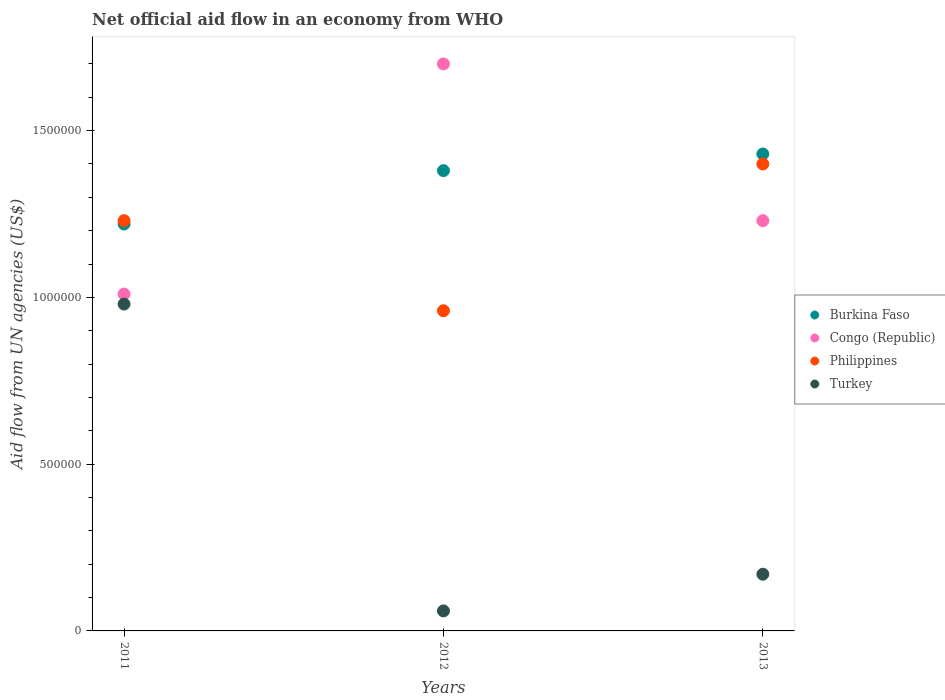Is the number of dotlines equal to the number of legend labels?
Offer a very short reply. Yes. What is the net official aid flow in Burkina Faso in 2012?
Offer a terse response. 1.38e+06. Across all years, what is the maximum net official aid flow in Philippines?
Your response must be concise. 1.40e+06. Across all years, what is the minimum net official aid flow in Burkina Faso?
Provide a short and direct response. 1.22e+06. In which year was the net official aid flow in Philippines maximum?
Make the answer very short. 2013. What is the total net official aid flow in Burkina Faso in the graph?
Give a very brief answer. 4.03e+06. What is the difference between the net official aid flow in Turkey in 2011 and that in 2012?
Keep it short and to the point. 9.20e+05. What is the difference between the net official aid flow in Turkey in 2013 and the net official aid flow in Congo (Republic) in 2012?
Keep it short and to the point. -1.53e+06. What is the average net official aid flow in Philippines per year?
Make the answer very short. 1.20e+06. In the year 2011, what is the difference between the net official aid flow in Philippines and net official aid flow in Burkina Faso?
Keep it short and to the point. 10000. What is the ratio of the net official aid flow in Congo (Republic) in 2012 to that in 2013?
Your answer should be very brief. 1.38. Is the net official aid flow in Philippines in 2012 less than that in 2013?
Ensure brevity in your answer.  Yes. What is the difference between the highest and the second highest net official aid flow in Turkey?
Ensure brevity in your answer.  8.10e+05. Is the sum of the net official aid flow in Congo (Republic) in 2012 and 2013 greater than the maximum net official aid flow in Turkey across all years?
Give a very brief answer. Yes. Is it the case that in every year, the sum of the net official aid flow in Burkina Faso and net official aid flow in Turkey  is greater than the sum of net official aid flow in Philippines and net official aid flow in Congo (Republic)?
Provide a short and direct response. No. Is it the case that in every year, the sum of the net official aid flow in Congo (Republic) and net official aid flow in Philippines  is greater than the net official aid flow in Burkina Faso?
Provide a short and direct response. Yes. Does the net official aid flow in Turkey monotonically increase over the years?
Provide a short and direct response. No. Is the net official aid flow in Philippines strictly greater than the net official aid flow in Congo (Republic) over the years?
Keep it short and to the point. No. How many dotlines are there?
Keep it short and to the point. 4. What is the difference between two consecutive major ticks on the Y-axis?
Offer a very short reply. 5.00e+05. Are the values on the major ticks of Y-axis written in scientific E-notation?
Provide a short and direct response. No. Does the graph contain any zero values?
Your response must be concise. No. Does the graph contain grids?
Your answer should be very brief. No. How many legend labels are there?
Make the answer very short. 4. What is the title of the graph?
Make the answer very short. Net official aid flow in an economy from WHO. Does "Euro area" appear as one of the legend labels in the graph?
Keep it short and to the point. No. What is the label or title of the X-axis?
Offer a very short reply. Years. What is the label or title of the Y-axis?
Your answer should be very brief. Aid flow from UN agencies (US$). What is the Aid flow from UN agencies (US$) of Burkina Faso in 2011?
Your answer should be very brief. 1.22e+06. What is the Aid flow from UN agencies (US$) of Congo (Republic) in 2011?
Offer a very short reply. 1.01e+06. What is the Aid flow from UN agencies (US$) of Philippines in 2011?
Make the answer very short. 1.23e+06. What is the Aid flow from UN agencies (US$) of Turkey in 2011?
Your answer should be very brief. 9.80e+05. What is the Aid flow from UN agencies (US$) in Burkina Faso in 2012?
Your response must be concise. 1.38e+06. What is the Aid flow from UN agencies (US$) in Congo (Republic) in 2012?
Offer a terse response. 1.70e+06. What is the Aid flow from UN agencies (US$) of Philippines in 2012?
Your answer should be very brief. 9.60e+05. What is the Aid flow from UN agencies (US$) of Turkey in 2012?
Your answer should be compact. 6.00e+04. What is the Aid flow from UN agencies (US$) of Burkina Faso in 2013?
Your response must be concise. 1.43e+06. What is the Aid flow from UN agencies (US$) of Congo (Republic) in 2013?
Keep it short and to the point. 1.23e+06. What is the Aid flow from UN agencies (US$) of Philippines in 2013?
Provide a succinct answer. 1.40e+06. What is the Aid flow from UN agencies (US$) in Turkey in 2013?
Your response must be concise. 1.70e+05. Across all years, what is the maximum Aid flow from UN agencies (US$) of Burkina Faso?
Ensure brevity in your answer.  1.43e+06. Across all years, what is the maximum Aid flow from UN agencies (US$) of Congo (Republic)?
Offer a very short reply. 1.70e+06. Across all years, what is the maximum Aid flow from UN agencies (US$) of Philippines?
Your response must be concise. 1.40e+06. Across all years, what is the maximum Aid flow from UN agencies (US$) of Turkey?
Your answer should be compact. 9.80e+05. Across all years, what is the minimum Aid flow from UN agencies (US$) in Burkina Faso?
Ensure brevity in your answer.  1.22e+06. Across all years, what is the minimum Aid flow from UN agencies (US$) in Congo (Republic)?
Your response must be concise. 1.01e+06. Across all years, what is the minimum Aid flow from UN agencies (US$) in Philippines?
Your answer should be compact. 9.60e+05. Across all years, what is the minimum Aid flow from UN agencies (US$) of Turkey?
Your answer should be compact. 6.00e+04. What is the total Aid flow from UN agencies (US$) in Burkina Faso in the graph?
Give a very brief answer. 4.03e+06. What is the total Aid flow from UN agencies (US$) in Congo (Republic) in the graph?
Offer a very short reply. 3.94e+06. What is the total Aid flow from UN agencies (US$) in Philippines in the graph?
Provide a succinct answer. 3.59e+06. What is the total Aid flow from UN agencies (US$) of Turkey in the graph?
Your response must be concise. 1.21e+06. What is the difference between the Aid flow from UN agencies (US$) of Congo (Republic) in 2011 and that in 2012?
Your answer should be compact. -6.90e+05. What is the difference between the Aid flow from UN agencies (US$) in Turkey in 2011 and that in 2012?
Ensure brevity in your answer.  9.20e+05. What is the difference between the Aid flow from UN agencies (US$) in Burkina Faso in 2011 and that in 2013?
Provide a short and direct response. -2.10e+05. What is the difference between the Aid flow from UN agencies (US$) in Philippines in 2011 and that in 2013?
Keep it short and to the point. -1.70e+05. What is the difference between the Aid flow from UN agencies (US$) in Turkey in 2011 and that in 2013?
Your answer should be compact. 8.10e+05. What is the difference between the Aid flow from UN agencies (US$) of Congo (Republic) in 2012 and that in 2013?
Your response must be concise. 4.70e+05. What is the difference between the Aid flow from UN agencies (US$) in Philippines in 2012 and that in 2013?
Your answer should be compact. -4.40e+05. What is the difference between the Aid flow from UN agencies (US$) of Turkey in 2012 and that in 2013?
Offer a terse response. -1.10e+05. What is the difference between the Aid flow from UN agencies (US$) in Burkina Faso in 2011 and the Aid flow from UN agencies (US$) in Congo (Republic) in 2012?
Ensure brevity in your answer.  -4.80e+05. What is the difference between the Aid flow from UN agencies (US$) in Burkina Faso in 2011 and the Aid flow from UN agencies (US$) in Philippines in 2012?
Provide a succinct answer. 2.60e+05. What is the difference between the Aid flow from UN agencies (US$) of Burkina Faso in 2011 and the Aid flow from UN agencies (US$) of Turkey in 2012?
Provide a succinct answer. 1.16e+06. What is the difference between the Aid flow from UN agencies (US$) in Congo (Republic) in 2011 and the Aid flow from UN agencies (US$) in Philippines in 2012?
Give a very brief answer. 5.00e+04. What is the difference between the Aid flow from UN agencies (US$) in Congo (Republic) in 2011 and the Aid flow from UN agencies (US$) in Turkey in 2012?
Make the answer very short. 9.50e+05. What is the difference between the Aid flow from UN agencies (US$) of Philippines in 2011 and the Aid flow from UN agencies (US$) of Turkey in 2012?
Your answer should be very brief. 1.17e+06. What is the difference between the Aid flow from UN agencies (US$) in Burkina Faso in 2011 and the Aid flow from UN agencies (US$) in Congo (Republic) in 2013?
Make the answer very short. -10000. What is the difference between the Aid flow from UN agencies (US$) in Burkina Faso in 2011 and the Aid flow from UN agencies (US$) in Turkey in 2013?
Provide a short and direct response. 1.05e+06. What is the difference between the Aid flow from UN agencies (US$) of Congo (Republic) in 2011 and the Aid flow from UN agencies (US$) of Philippines in 2013?
Provide a succinct answer. -3.90e+05. What is the difference between the Aid flow from UN agencies (US$) in Congo (Republic) in 2011 and the Aid flow from UN agencies (US$) in Turkey in 2013?
Offer a terse response. 8.40e+05. What is the difference between the Aid flow from UN agencies (US$) of Philippines in 2011 and the Aid flow from UN agencies (US$) of Turkey in 2013?
Provide a succinct answer. 1.06e+06. What is the difference between the Aid flow from UN agencies (US$) of Burkina Faso in 2012 and the Aid flow from UN agencies (US$) of Philippines in 2013?
Provide a short and direct response. -2.00e+04. What is the difference between the Aid flow from UN agencies (US$) of Burkina Faso in 2012 and the Aid flow from UN agencies (US$) of Turkey in 2013?
Your answer should be compact. 1.21e+06. What is the difference between the Aid flow from UN agencies (US$) of Congo (Republic) in 2012 and the Aid flow from UN agencies (US$) of Philippines in 2013?
Ensure brevity in your answer.  3.00e+05. What is the difference between the Aid flow from UN agencies (US$) of Congo (Republic) in 2012 and the Aid flow from UN agencies (US$) of Turkey in 2013?
Your answer should be very brief. 1.53e+06. What is the difference between the Aid flow from UN agencies (US$) of Philippines in 2012 and the Aid flow from UN agencies (US$) of Turkey in 2013?
Your answer should be very brief. 7.90e+05. What is the average Aid flow from UN agencies (US$) in Burkina Faso per year?
Your answer should be compact. 1.34e+06. What is the average Aid flow from UN agencies (US$) in Congo (Republic) per year?
Give a very brief answer. 1.31e+06. What is the average Aid flow from UN agencies (US$) in Philippines per year?
Your response must be concise. 1.20e+06. What is the average Aid flow from UN agencies (US$) in Turkey per year?
Give a very brief answer. 4.03e+05. In the year 2011, what is the difference between the Aid flow from UN agencies (US$) of Burkina Faso and Aid flow from UN agencies (US$) of Congo (Republic)?
Provide a succinct answer. 2.10e+05. In the year 2011, what is the difference between the Aid flow from UN agencies (US$) of Congo (Republic) and Aid flow from UN agencies (US$) of Turkey?
Give a very brief answer. 3.00e+04. In the year 2012, what is the difference between the Aid flow from UN agencies (US$) of Burkina Faso and Aid flow from UN agencies (US$) of Congo (Republic)?
Keep it short and to the point. -3.20e+05. In the year 2012, what is the difference between the Aid flow from UN agencies (US$) of Burkina Faso and Aid flow from UN agencies (US$) of Philippines?
Make the answer very short. 4.20e+05. In the year 2012, what is the difference between the Aid flow from UN agencies (US$) in Burkina Faso and Aid flow from UN agencies (US$) in Turkey?
Your response must be concise. 1.32e+06. In the year 2012, what is the difference between the Aid flow from UN agencies (US$) in Congo (Republic) and Aid flow from UN agencies (US$) in Philippines?
Offer a very short reply. 7.40e+05. In the year 2012, what is the difference between the Aid flow from UN agencies (US$) in Congo (Republic) and Aid flow from UN agencies (US$) in Turkey?
Keep it short and to the point. 1.64e+06. In the year 2012, what is the difference between the Aid flow from UN agencies (US$) in Philippines and Aid flow from UN agencies (US$) in Turkey?
Provide a succinct answer. 9.00e+05. In the year 2013, what is the difference between the Aid flow from UN agencies (US$) of Burkina Faso and Aid flow from UN agencies (US$) of Turkey?
Provide a short and direct response. 1.26e+06. In the year 2013, what is the difference between the Aid flow from UN agencies (US$) in Congo (Republic) and Aid flow from UN agencies (US$) in Turkey?
Your answer should be compact. 1.06e+06. In the year 2013, what is the difference between the Aid flow from UN agencies (US$) of Philippines and Aid flow from UN agencies (US$) of Turkey?
Keep it short and to the point. 1.23e+06. What is the ratio of the Aid flow from UN agencies (US$) of Burkina Faso in 2011 to that in 2012?
Your response must be concise. 0.88. What is the ratio of the Aid flow from UN agencies (US$) in Congo (Republic) in 2011 to that in 2012?
Your answer should be compact. 0.59. What is the ratio of the Aid flow from UN agencies (US$) in Philippines in 2011 to that in 2012?
Provide a short and direct response. 1.28. What is the ratio of the Aid flow from UN agencies (US$) of Turkey in 2011 to that in 2012?
Your answer should be compact. 16.33. What is the ratio of the Aid flow from UN agencies (US$) in Burkina Faso in 2011 to that in 2013?
Make the answer very short. 0.85. What is the ratio of the Aid flow from UN agencies (US$) of Congo (Republic) in 2011 to that in 2013?
Make the answer very short. 0.82. What is the ratio of the Aid flow from UN agencies (US$) in Philippines in 2011 to that in 2013?
Offer a terse response. 0.88. What is the ratio of the Aid flow from UN agencies (US$) in Turkey in 2011 to that in 2013?
Offer a very short reply. 5.76. What is the ratio of the Aid flow from UN agencies (US$) in Burkina Faso in 2012 to that in 2013?
Provide a short and direct response. 0.96. What is the ratio of the Aid flow from UN agencies (US$) in Congo (Republic) in 2012 to that in 2013?
Give a very brief answer. 1.38. What is the ratio of the Aid flow from UN agencies (US$) of Philippines in 2012 to that in 2013?
Give a very brief answer. 0.69. What is the ratio of the Aid flow from UN agencies (US$) in Turkey in 2012 to that in 2013?
Keep it short and to the point. 0.35. What is the difference between the highest and the second highest Aid flow from UN agencies (US$) in Philippines?
Your answer should be compact. 1.70e+05. What is the difference between the highest and the second highest Aid flow from UN agencies (US$) in Turkey?
Provide a succinct answer. 8.10e+05. What is the difference between the highest and the lowest Aid flow from UN agencies (US$) of Burkina Faso?
Your answer should be compact. 2.10e+05. What is the difference between the highest and the lowest Aid flow from UN agencies (US$) of Congo (Republic)?
Your answer should be compact. 6.90e+05. What is the difference between the highest and the lowest Aid flow from UN agencies (US$) in Philippines?
Provide a succinct answer. 4.40e+05. What is the difference between the highest and the lowest Aid flow from UN agencies (US$) in Turkey?
Your answer should be compact. 9.20e+05. 